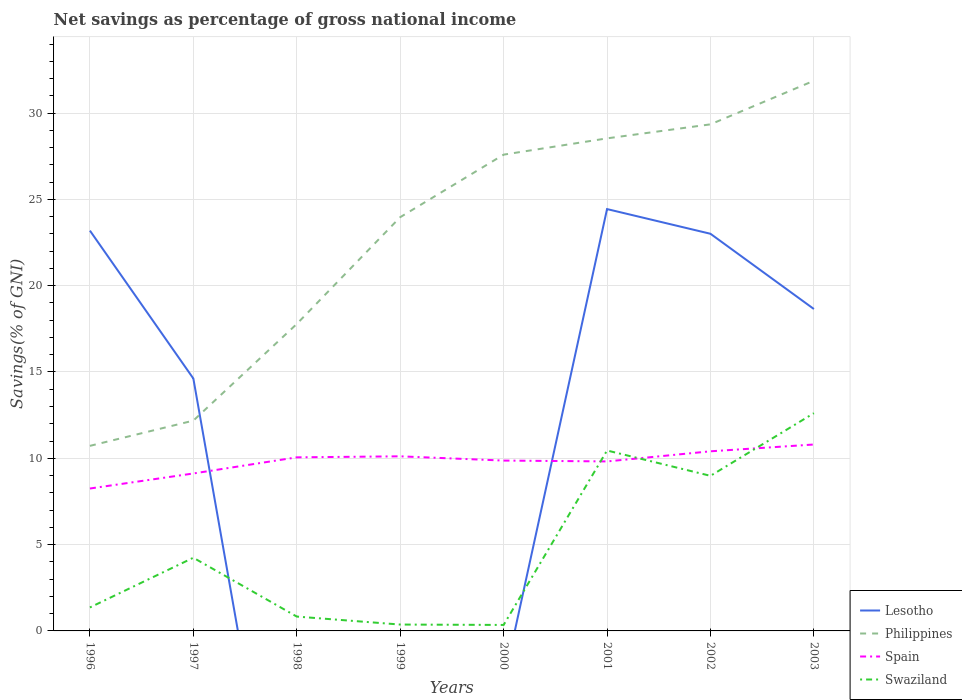Across all years, what is the maximum total savings in Lesotho?
Make the answer very short. 0. What is the total total savings in Swaziland in the graph?
Give a very brief answer. -8.62. What is the difference between the highest and the second highest total savings in Philippines?
Provide a succinct answer. 21.15. What is the difference between the highest and the lowest total savings in Spain?
Your answer should be very brief. 6. Is the total savings in Lesotho strictly greater than the total savings in Philippines over the years?
Keep it short and to the point. No. How many lines are there?
Your answer should be compact. 4. How many years are there in the graph?
Give a very brief answer. 8. What is the difference between two consecutive major ticks on the Y-axis?
Your answer should be very brief. 5. Are the values on the major ticks of Y-axis written in scientific E-notation?
Your answer should be very brief. No. Does the graph contain grids?
Your response must be concise. Yes. What is the title of the graph?
Offer a terse response. Net savings as percentage of gross national income. Does "Ireland" appear as one of the legend labels in the graph?
Offer a very short reply. No. What is the label or title of the Y-axis?
Provide a short and direct response. Savings(% of GNI). What is the Savings(% of GNI) in Lesotho in 1996?
Your answer should be very brief. 23.19. What is the Savings(% of GNI) of Philippines in 1996?
Give a very brief answer. 10.72. What is the Savings(% of GNI) in Spain in 1996?
Provide a succinct answer. 8.25. What is the Savings(% of GNI) in Swaziland in 1996?
Make the answer very short. 1.36. What is the Savings(% of GNI) in Lesotho in 1997?
Your response must be concise. 14.62. What is the Savings(% of GNI) of Philippines in 1997?
Provide a succinct answer. 12.18. What is the Savings(% of GNI) of Spain in 1997?
Keep it short and to the point. 9.12. What is the Savings(% of GNI) in Swaziland in 1997?
Your response must be concise. 4.24. What is the Savings(% of GNI) in Lesotho in 1998?
Offer a very short reply. 0. What is the Savings(% of GNI) in Philippines in 1998?
Ensure brevity in your answer.  17.78. What is the Savings(% of GNI) of Spain in 1998?
Ensure brevity in your answer.  10.06. What is the Savings(% of GNI) of Swaziland in 1998?
Provide a succinct answer. 0.83. What is the Savings(% of GNI) of Lesotho in 1999?
Keep it short and to the point. 0. What is the Savings(% of GNI) of Philippines in 1999?
Your answer should be very brief. 23.97. What is the Savings(% of GNI) in Spain in 1999?
Offer a terse response. 10.12. What is the Savings(% of GNI) of Swaziland in 1999?
Keep it short and to the point. 0.37. What is the Savings(% of GNI) in Lesotho in 2000?
Provide a succinct answer. 0. What is the Savings(% of GNI) in Philippines in 2000?
Your answer should be compact. 27.59. What is the Savings(% of GNI) in Spain in 2000?
Provide a short and direct response. 9.87. What is the Savings(% of GNI) in Swaziland in 2000?
Make the answer very short. 0.35. What is the Savings(% of GNI) of Lesotho in 2001?
Offer a very short reply. 24.44. What is the Savings(% of GNI) in Philippines in 2001?
Your response must be concise. 28.54. What is the Savings(% of GNI) of Spain in 2001?
Keep it short and to the point. 9.82. What is the Savings(% of GNI) in Swaziland in 2001?
Your response must be concise. 10.45. What is the Savings(% of GNI) of Lesotho in 2002?
Give a very brief answer. 23.01. What is the Savings(% of GNI) of Philippines in 2002?
Provide a short and direct response. 29.35. What is the Savings(% of GNI) in Spain in 2002?
Your response must be concise. 10.41. What is the Savings(% of GNI) in Swaziland in 2002?
Ensure brevity in your answer.  8.98. What is the Savings(% of GNI) in Lesotho in 2003?
Provide a succinct answer. 18.65. What is the Savings(% of GNI) of Philippines in 2003?
Give a very brief answer. 31.87. What is the Savings(% of GNI) in Spain in 2003?
Make the answer very short. 10.8. What is the Savings(% of GNI) of Swaziland in 2003?
Provide a short and direct response. 12.61. Across all years, what is the maximum Savings(% of GNI) of Lesotho?
Ensure brevity in your answer.  24.44. Across all years, what is the maximum Savings(% of GNI) of Philippines?
Your answer should be very brief. 31.87. Across all years, what is the maximum Savings(% of GNI) in Spain?
Your answer should be very brief. 10.8. Across all years, what is the maximum Savings(% of GNI) of Swaziland?
Provide a short and direct response. 12.61. Across all years, what is the minimum Savings(% of GNI) of Lesotho?
Provide a succinct answer. 0. Across all years, what is the minimum Savings(% of GNI) in Philippines?
Your answer should be compact. 10.72. Across all years, what is the minimum Savings(% of GNI) of Spain?
Give a very brief answer. 8.25. Across all years, what is the minimum Savings(% of GNI) of Swaziland?
Offer a terse response. 0.35. What is the total Savings(% of GNI) in Lesotho in the graph?
Offer a terse response. 103.91. What is the total Savings(% of GNI) of Philippines in the graph?
Provide a succinct answer. 182. What is the total Savings(% of GNI) in Spain in the graph?
Offer a very short reply. 78.43. What is the total Savings(% of GNI) in Swaziland in the graph?
Your response must be concise. 39.2. What is the difference between the Savings(% of GNI) in Lesotho in 1996 and that in 1997?
Provide a short and direct response. 8.57. What is the difference between the Savings(% of GNI) in Philippines in 1996 and that in 1997?
Provide a short and direct response. -1.46. What is the difference between the Savings(% of GNI) of Spain in 1996 and that in 1997?
Your response must be concise. -0.87. What is the difference between the Savings(% of GNI) in Swaziland in 1996 and that in 1997?
Make the answer very short. -2.88. What is the difference between the Savings(% of GNI) of Philippines in 1996 and that in 1998?
Offer a very short reply. -7.06. What is the difference between the Savings(% of GNI) in Spain in 1996 and that in 1998?
Offer a terse response. -1.81. What is the difference between the Savings(% of GNI) in Swaziland in 1996 and that in 1998?
Your answer should be very brief. 0.53. What is the difference between the Savings(% of GNI) in Philippines in 1996 and that in 1999?
Keep it short and to the point. -13.25. What is the difference between the Savings(% of GNI) in Spain in 1996 and that in 1999?
Provide a succinct answer. -1.87. What is the difference between the Savings(% of GNI) of Swaziland in 1996 and that in 1999?
Provide a succinct answer. 0.99. What is the difference between the Savings(% of GNI) in Philippines in 1996 and that in 2000?
Give a very brief answer. -16.87. What is the difference between the Savings(% of GNI) in Spain in 1996 and that in 2000?
Your response must be concise. -1.62. What is the difference between the Savings(% of GNI) of Swaziland in 1996 and that in 2000?
Provide a short and direct response. 1.01. What is the difference between the Savings(% of GNI) of Lesotho in 1996 and that in 2001?
Keep it short and to the point. -1.25. What is the difference between the Savings(% of GNI) of Philippines in 1996 and that in 2001?
Ensure brevity in your answer.  -17.81. What is the difference between the Savings(% of GNI) in Spain in 1996 and that in 2001?
Provide a succinct answer. -1.57. What is the difference between the Savings(% of GNI) in Swaziland in 1996 and that in 2001?
Your answer should be very brief. -9.09. What is the difference between the Savings(% of GNI) of Lesotho in 1996 and that in 2002?
Offer a very short reply. 0.18. What is the difference between the Savings(% of GNI) of Philippines in 1996 and that in 2002?
Make the answer very short. -18.63. What is the difference between the Savings(% of GNI) in Spain in 1996 and that in 2002?
Make the answer very short. -2.16. What is the difference between the Savings(% of GNI) of Swaziland in 1996 and that in 2002?
Your response must be concise. -7.62. What is the difference between the Savings(% of GNI) of Lesotho in 1996 and that in 2003?
Provide a short and direct response. 4.54. What is the difference between the Savings(% of GNI) in Philippines in 1996 and that in 2003?
Provide a succinct answer. -21.15. What is the difference between the Savings(% of GNI) of Spain in 1996 and that in 2003?
Your answer should be compact. -2.55. What is the difference between the Savings(% of GNI) in Swaziland in 1996 and that in 2003?
Ensure brevity in your answer.  -11.25. What is the difference between the Savings(% of GNI) in Philippines in 1997 and that in 1998?
Offer a terse response. -5.6. What is the difference between the Savings(% of GNI) in Spain in 1997 and that in 1998?
Give a very brief answer. -0.93. What is the difference between the Savings(% of GNI) in Swaziland in 1997 and that in 1998?
Your answer should be compact. 3.41. What is the difference between the Savings(% of GNI) in Philippines in 1997 and that in 1999?
Provide a succinct answer. -11.79. What is the difference between the Savings(% of GNI) in Spain in 1997 and that in 1999?
Your answer should be very brief. -0.99. What is the difference between the Savings(% of GNI) of Swaziland in 1997 and that in 1999?
Your response must be concise. 3.87. What is the difference between the Savings(% of GNI) in Philippines in 1997 and that in 2000?
Offer a very short reply. -15.41. What is the difference between the Savings(% of GNI) of Spain in 1997 and that in 2000?
Keep it short and to the point. -0.75. What is the difference between the Savings(% of GNI) of Swaziland in 1997 and that in 2000?
Your response must be concise. 3.89. What is the difference between the Savings(% of GNI) in Lesotho in 1997 and that in 2001?
Your response must be concise. -9.81. What is the difference between the Savings(% of GNI) in Philippines in 1997 and that in 2001?
Offer a very short reply. -16.35. What is the difference between the Savings(% of GNI) of Spain in 1997 and that in 2001?
Ensure brevity in your answer.  -0.7. What is the difference between the Savings(% of GNI) of Swaziland in 1997 and that in 2001?
Offer a very short reply. -6.21. What is the difference between the Savings(% of GNI) of Lesotho in 1997 and that in 2002?
Provide a succinct answer. -8.38. What is the difference between the Savings(% of GNI) of Philippines in 1997 and that in 2002?
Give a very brief answer. -17.16. What is the difference between the Savings(% of GNI) in Spain in 1997 and that in 2002?
Provide a succinct answer. -1.28. What is the difference between the Savings(% of GNI) in Swaziland in 1997 and that in 2002?
Provide a succinct answer. -4.75. What is the difference between the Savings(% of GNI) in Lesotho in 1997 and that in 2003?
Keep it short and to the point. -4.03. What is the difference between the Savings(% of GNI) of Philippines in 1997 and that in 2003?
Give a very brief answer. -19.69. What is the difference between the Savings(% of GNI) in Spain in 1997 and that in 2003?
Keep it short and to the point. -1.68. What is the difference between the Savings(% of GNI) in Swaziland in 1997 and that in 2003?
Give a very brief answer. -8.37. What is the difference between the Savings(% of GNI) in Philippines in 1998 and that in 1999?
Your response must be concise. -6.19. What is the difference between the Savings(% of GNI) in Spain in 1998 and that in 1999?
Offer a terse response. -0.06. What is the difference between the Savings(% of GNI) in Swaziland in 1998 and that in 1999?
Ensure brevity in your answer.  0.46. What is the difference between the Savings(% of GNI) in Philippines in 1998 and that in 2000?
Provide a succinct answer. -9.81. What is the difference between the Savings(% of GNI) in Spain in 1998 and that in 2000?
Provide a short and direct response. 0.19. What is the difference between the Savings(% of GNI) in Swaziland in 1998 and that in 2000?
Ensure brevity in your answer.  0.48. What is the difference between the Savings(% of GNI) in Philippines in 1998 and that in 2001?
Give a very brief answer. -10.75. What is the difference between the Savings(% of GNI) in Spain in 1998 and that in 2001?
Make the answer very short. 0.24. What is the difference between the Savings(% of GNI) in Swaziland in 1998 and that in 2001?
Offer a terse response. -9.62. What is the difference between the Savings(% of GNI) in Philippines in 1998 and that in 2002?
Provide a short and direct response. -11.56. What is the difference between the Savings(% of GNI) in Spain in 1998 and that in 2002?
Give a very brief answer. -0.35. What is the difference between the Savings(% of GNI) in Swaziland in 1998 and that in 2002?
Your response must be concise. -8.15. What is the difference between the Savings(% of GNI) of Philippines in 1998 and that in 2003?
Keep it short and to the point. -14.09. What is the difference between the Savings(% of GNI) of Spain in 1998 and that in 2003?
Offer a terse response. -0.74. What is the difference between the Savings(% of GNI) of Swaziland in 1998 and that in 2003?
Ensure brevity in your answer.  -11.78. What is the difference between the Savings(% of GNI) in Philippines in 1999 and that in 2000?
Your answer should be compact. -3.62. What is the difference between the Savings(% of GNI) in Spain in 1999 and that in 2000?
Your answer should be compact. 0.25. What is the difference between the Savings(% of GNI) in Swaziland in 1999 and that in 2000?
Offer a terse response. 0.02. What is the difference between the Savings(% of GNI) of Philippines in 1999 and that in 2001?
Provide a short and direct response. -4.57. What is the difference between the Savings(% of GNI) of Spain in 1999 and that in 2001?
Provide a succinct answer. 0.3. What is the difference between the Savings(% of GNI) in Swaziland in 1999 and that in 2001?
Provide a succinct answer. -10.08. What is the difference between the Savings(% of GNI) in Philippines in 1999 and that in 2002?
Ensure brevity in your answer.  -5.38. What is the difference between the Savings(% of GNI) in Spain in 1999 and that in 2002?
Your answer should be compact. -0.29. What is the difference between the Savings(% of GNI) of Swaziland in 1999 and that in 2002?
Your response must be concise. -8.62. What is the difference between the Savings(% of GNI) of Philippines in 1999 and that in 2003?
Your response must be concise. -7.9. What is the difference between the Savings(% of GNI) of Spain in 1999 and that in 2003?
Provide a succinct answer. -0.68. What is the difference between the Savings(% of GNI) in Swaziland in 1999 and that in 2003?
Provide a succinct answer. -12.24. What is the difference between the Savings(% of GNI) of Philippines in 2000 and that in 2001?
Give a very brief answer. -0.94. What is the difference between the Savings(% of GNI) in Spain in 2000 and that in 2001?
Provide a short and direct response. 0.05. What is the difference between the Savings(% of GNI) in Swaziland in 2000 and that in 2001?
Your response must be concise. -10.11. What is the difference between the Savings(% of GNI) of Philippines in 2000 and that in 2002?
Offer a terse response. -1.76. What is the difference between the Savings(% of GNI) in Spain in 2000 and that in 2002?
Your answer should be compact. -0.54. What is the difference between the Savings(% of GNI) in Swaziland in 2000 and that in 2002?
Your answer should be very brief. -8.64. What is the difference between the Savings(% of GNI) in Philippines in 2000 and that in 2003?
Make the answer very short. -4.28. What is the difference between the Savings(% of GNI) in Spain in 2000 and that in 2003?
Give a very brief answer. -0.93. What is the difference between the Savings(% of GNI) in Swaziland in 2000 and that in 2003?
Provide a short and direct response. -12.27. What is the difference between the Savings(% of GNI) of Lesotho in 2001 and that in 2002?
Make the answer very short. 1.43. What is the difference between the Savings(% of GNI) in Philippines in 2001 and that in 2002?
Provide a succinct answer. -0.81. What is the difference between the Savings(% of GNI) of Spain in 2001 and that in 2002?
Make the answer very short. -0.59. What is the difference between the Savings(% of GNI) in Swaziland in 2001 and that in 2002?
Your answer should be very brief. 1.47. What is the difference between the Savings(% of GNI) in Lesotho in 2001 and that in 2003?
Keep it short and to the point. 5.79. What is the difference between the Savings(% of GNI) in Philippines in 2001 and that in 2003?
Provide a short and direct response. -3.34. What is the difference between the Savings(% of GNI) in Spain in 2001 and that in 2003?
Provide a short and direct response. -0.98. What is the difference between the Savings(% of GNI) of Swaziland in 2001 and that in 2003?
Offer a very short reply. -2.16. What is the difference between the Savings(% of GNI) in Lesotho in 2002 and that in 2003?
Provide a succinct answer. 4.36. What is the difference between the Savings(% of GNI) in Philippines in 2002 and that in 2003?
Your answer should be compact. -2.53. What is the difference between the Savings(% of GNI) in Spain in 2002 and that in 2003?
Your answer should be very brief. -0.39. What is the difference between the Savings(% of GNI) of Swaziland in 2002 and that in 2003?
Keep it short and to the point. -3.63. What is the difference between the Savings(% of GNI) of Lesotho in 1996 and the Savings(% of GNI) of Philippines in 1997?
Your answer should be compact. 11.01. What is the difference between the Savings(% of GNI) in Lesotho in 1996 and the Savings(% of GNI) in Spain in 1997?
Give a very brief answer. 14.07. What is the difference between the Savings(% of GNI) in Lesotho in 1996 and the Savings(% of GNI) in Swaziland in 1997?
Offer a very short reply. 18.95. What is the difference between the Savings(% of GNI) in Philippines in 1996 and the Savings(% of GNI) in Spain in 1997?
Offer a very short reply. 1.6. What is the difference between the Savings(% of GNI) of Philippines in 1996 and the Savings(% of GNI) of Swaziland in 1997?
Make the answer very short. 6.48. What is the difference between the Savings(% of GNI) in Spain in 1996 and the Savings(% of GNI) in Swaziland in 1997?
Provide a short and direct response. 4.01. What is the difference between the Savings(% of GNI) in Lesotho in 1996 and the Savings(% of GNI) in Philippines in 1998?
Your answer should be compact. 5.41. What is the difference between the Savings(% of GNI) in Lesotho in 1996 and the Savings(% of GNI) in Spain in 1998?
Your answer should be compact. 13.13. What is the difference between the Savings(% of GNI) of Lesotho in 1996 and the Savings(% of GNI) of Swaziland in 1998?
Give a very brief answer. 22.36. What is the difference between the Savings(% of GNI) in Philippines in 1996 and the Savings(% of GNI) in Spain in 1998?
Make the answer very short. 0.67. What is the difference between the Savings(% of GNI) of Philippines in 1996 and the Savings(% of GNI) of Swaziland in 1998?
Provide a short and direct response. 9.89. What is the difference between the Savings(% of GNI) in Spain in 1996 and the Savings(% of GNI) in Swaziland in 1998?
Offer a very short reply. 7.42. What is the difference between the Savings(% of GNI) of Lesotho in 1996 and the Savings(% of GNI) of Philippines in 1999?
Make the answer very short. -0.78. What is the difference between the Savings(% of GNI) in Lesotho in 1996 and the Savings(% of GNI) in Spain in 1999?
Offer a terse response. 13.08. What is the difference between the Savings(% of GNI) of Lesotho in 1996 and the Savings(% of GNI) of Swaziland in 1999?
Your answer should be very brief. 22.82. What is the difference between the Savings(% of GNI) in Philippines in 1996 and the Savings(% of GNI) in Spain in 1999?
Give a very brief answer. 0.61. What is the difference between the Savings(% of GNI) in Philippines in 1996 and the Savings(% of GNI) in Swaziland in 1999?
Make the answer very short. 10.35. What is the difference between the Savings(% of GNI) of Spain in 1996 and the Savings(% of GNI) of Swaziland in 1999?
Make the answer very short. 7.88. What is the difference between the Savings(% of GNI) of Lesotho in 1996 and the Savings(% of GNI) of Philippines in 2000?
Your response must be concise. -4.4. What is the difference between the Savings(% of GNI) of Lesotho in 1996 and the Savings(% of GNI) of Spain in 2000?
Make the answer very short. 13.32. What is the difference between the Savings(% of GNI) in Lesotho in 1996 and the Savings(% of GNI) in Swaziland in 2000?
Keep it short and to the point. 22.84. What is the difference between the Savings(% of GNI) of Philippines in 1996 and the Savings(% of GNI) of Spain in 2000?
Provide a succinct answer. 0.85. What is the difference between the Savings(% of GNI) of Philippines in 1996 and the Savings(% of GNI) of Swaziland in 2000?
Your answer should be compact. 10.37. What is the difference between the Savings(% of GNI) of Spain in 1996 and the Savings(% of GNI) of Swaziland in 2000?
Offer a terse response. 7.9. What is the difference between the Savings(% of GNI) of Lesotho in 1996 and the Savings(% of GNI) of Philippines in 2001?
Offer a very short reply. -5.34. What is the difference between the Savings(% of GNI) in Lesotho in 1996 and the Savings(% of GNI) in Spain in 2001?
Your answer should be compact. 13.37. What is the difference between the Savings(% of GNI) in Lesotho in 1996 and the Savings(% of GNI) in Swaziland in 2001?
Your answer should be compact. 12.74. What is the difference between the Savings(% of GNI) in Philippines in 1996 and the Savings(% of GNI) in Spain in 2001?
Your response must be concise. 0.9. What is the difference between the Savings(% of GNI) in Philippines in 1996 and the Savings(% of GNI) in Swaziland in 2001?
Your answer should be compact. 0.27. What is the difference between the Savings(% of GNI) in Spain in 1996 and the Savings(% of GNI) in Swaziland in 2001?
Your response must be concise. -2.2. What is the difference between the Savings(% of GNI) of Lesotho in 1996 and the Savings(% of GNI) of Philippines in 2002?
Your response must be concise. -6.16. What is the difference between the Savings(% of GNI) in Lesotho in 1996 and the Savings(% of GNI) in Spain in 2002?
Your answer should be very brief. 12.79. What is the difference between the Savings(% of GNI) of Lesotho in 1996 and the Savings(% of GNI) of Swaziland in 2002?
Your response must be concise. 14.21. What is the difference between the Savings(% of GNI) of Philippines in 1996 and the Savings(% of GNI) of Spain in 2002?
Your answer should be compact. 0.32. What is the difference between the Savings(% of GNI) of Philippines in 1996 and the Savings(% of GNI) of Swaziland in 2002?
Keep it short and to the point. 1.74. What is the difference between the Savings(% of GNI) in Spain in 1996 and the Savings(% of GNI) in Swaziland in 2002?
Make the answer very short. -0.73. What is the difference between the Savings(% of GNI) of Lesotho in 1996 and the Savings(% of GNI) of Philippines in 2003?
Make the answer very short. -8.68. What is the difference between the Savings(% of GNI) in Lesotho in 1996 and the Savings(% of GNI) in Spain in 2003?
Make the answer very short. 12.39. What is the difference between the Savings(% of GNI) in Lesotho in 1996 and the Savings(% of GNI) in Swaziland in 2003?
Make the answer very short. 10.58. What is the difference between the Savings(% of GNI) of Philippines in 1996 and the Savings(% of GNI) of Spain in 2003?
Ensure brevity in your answer.  -0.08. What is the difference between the Savings(% of GNI) in Philippines in 1996 and the Savings(% of GNI) in Swaziland in 2003?
Give a very brief answer. -1.89. What is the difference between the Savings(% of GNI) in Spain in 1996 and the Savings(% of GNI) in Swaziland in 2003?
Give a very brief answer. -4.36. What is the difference between the Savings(% of GNI) of Lesotho in 1997 and the Savings(% of GNI) of Philippines in 1998?
Provide a short and direct response. -3.16. What is the difference between the Savings(% of GNI) in Lesotho in 1997 and the Savings(% of GNI) in Spain in 1998?
Your response must be concise. 4.57. What is the difference between the Savings(% of GNI) in Lesotho in 1997 and the Savings(% of GNI) in Swaziland in 1998?
Make the answer very short. 13.79. What is the difference between the Savings(% of GNI) in Philippines in 1997 and the Savings(% of GNI) in Spain in 1998?
Give a very brief answer. 2.13. What is the difference between the Savings(% of GNI) in Philippines in 1997 and the Savings(% of GNI) in Swaziland in 1998?
Your response must be concise. 11.35. What is the difference between the Savings(% of GNI) of Spain in 1997 and the Savings(% of GNI) of Swaziland in 1998?
Provide a succinct answer. 8.29. What is the difference between the Savings(% of GNI) of Lesotho in 1997 and the Savings(% of GNI) of Philippines in 1999?
Your answer should be compact. -9.34. What is the difference between the Savings(% of GNI) of Lesotho in 1997 and the Savings(% of GNI) of Spain in 1999?
Your answer should be compact. 4.51. What is the difference between the Savings(% of GNI) in Lesotho in 1997 and the Savings(% of GNI) in Swaziland in 1999?
Make the answer very short. 14.25. What is the difference between the Savings(% of GNI) of Philippines in 1997 and the Savings(% of GNI) of Spain in 1999?
Your response must be concise. 2.07. What is the difference between the Savings(% of GNI) of Philippines in 1997 and the Savings(% of GNI) of Swaziland in 1999?
Provide a succinct answer. 11.81. What is the difference between the Savings(% of GNI) of Spain in 1997 and the Savings(% of GNI) of Swaziland in 1999?
Your answer should be very brief. 8.75. What is the difference between the Savings(% of GNI) of Lesotho in 1997 and the Savings(% of GNI) of Philippines in 2000?
Provide a short and direct response. -12.97. What is the difference between the Savings(% of GNI) of Lesotho in 1997 and the Savings(% of GNI) of Spain in 2000?
Make the answer very short. 4.75. What is the difference between the Savings(% of GNI) of Lesotho in 1997 and the Savings(% of GNI) of Swaziland in 2000?
Keep it short and to the point. 14.28. What is the difference between the Savings(% of GNI) of Philippines in 1997 and the Savings(% of GNI) of Spain in 2000?
Offer a terse response. 2.31. What is the difference between the Savings(% of GNI) in Philippines in 1997 and the Savings(% of GNI) in Swaziland in 2000?
Give a very brief answer. 11.84. What is the difference between the Savings(% of GNI) of Spain in 1997 and the Savings(% of GNI) of Swaziland in 2000?
Your answer should be compact. 8.77. What is the difference between the Savings(% of GNI) in Lesotho in 1997 and the Savings(% of GNI) in Philippines in 2001?
Keep it short and to the point. -13.91. What is the difference between the Savings(% of GNI) in Lesotho in 1997 and the Savings(% of GNI) in Spain in 2001?
Your answer should be very brief. 4.8. What is the difference between the Savings(% of GNI) of Lesotho in 1997 and the Savings(% of GNI) of Swaziland in 2001?
Offer a very short reply. 4.17. What is the difference between the Savings(% of GNI) in Philippines in 1997 and the Savings(% of GNI) in Spain in 2001?
Provide a succinct answer. 2.36. What is the difference between the Savings(% of GNI) in Philippines in 1997 and the Savings(% of GNI) in Swaziland in 2001?
Provide a succinct answer. 1.73. What is the difference between the Savings(% of GNI) of Spain in 1997 and the Savings(% of GNI) of Swaziland in 2001?
Offer a very short reply. -1.33. What is the difference between the Savings(% of GNI) in Lesotho in 1997 and the Savings(% of GNI) in Philippines in 2002?
Your answer should be very brief. -14.72. What is the difference between the Savings(% of GNI) of Lesotho in 1997 and the Savings(% of GNI) of Spain in 2002?
Offer a very short reply. 4.22. What is the difference between the Savings(% of GNI) of Lesotho in 1997 and the Savings(% of GNI) of Swaziland in 2002?
Make the answer very short. 5.64. What is the difference between the Savings(% of GNI) of Philippines in 1997 and the Savings(% of GNI) of Spain in 2002?
Provide a short and direct response. 1.78. What is the difference between the Savings(% of GNI) of Philippines in 1997 and the Savings(% of GNI) of Swaziland in 2002?
Your answer should be very brief. 3.2. What is the difference between the Savings(% of GNI) of Spain in 1997 and the Savings(% of GNI) of Swaziland in 2002?
Offer a terse response. 0.14. What is the difference between the Savings(% of GNI) of Lesotho in 1997 and the Savings(% of GNI) of Philippines in 2003?
Provide a short and direct response. -17.25. What is the difference between the Savings(% of GNI) in Lesotho in 1997 and the Savings(% of GNI) in Spain in 2003?
Keep it short and to the point. 3.82. What is the difference between the Savings(% of GNI) in Lesotho in 1997 and the Savings(% of GNI) in Swaziland in 2003?
Offer a terse response. 2.01. What is the difference between the Savings(% of GNI) in Philippines in 1997 and the Savings(% of GNI) in Spain in 2003?
Your response must be concise. 1.38. What is the difference between the Savings(% of GNI) in Philippines in 1997 and the Savings(% of GNI) in Swaziland in 2003?
Your response must be concise. -0.43. What is the difference between the Savings(% of GNI) of Spain in 1997 and the Savings(% of GNI) of Swaziland in 2003?
Your answer should be compact. -3.49. What is the difference between the Savings(% of GNI) in Philippines in 1998 and the Savings(% of GNI) in Spain in 1999?
Your response must be concise. 7.67. What is the difference between the Savings(% of GNI) of Philippines in 1998 and the Savings(% of GNI) of Swaziland in 1999?
Make the answer very short. 17.41. What is the difference between the Savings(% of GNI) in Spain in 1998 and the Savings(% of GNI) in Swaziland in 1999?
Your response must be concise. 9.69. What is the difference between the Savings(% of GNI) in Philippines in 1998 and the Savings(% of GNI) in Spain in 2000?
Your answer should be compact. 7.91. What is the difference between the Savings(% of GNI) of Philippines in 1998 and the Savings(% of GNI) of Swaziland in 2000?
Your answer should be very brief. 17.44. What is the difference between the Savings(% of GNI) in Spain in 1998 and the Savings(% of GNI) in Swaziland in 2000?
Keep it short and to the point. 9.71. What is the difference between the Savings(% of GNI) of Philippines in 1998 and the Savings(% of GNI) of Spain in 2001?
Your response must be concise. 7.96. What is the difference between the Savings(% of GNI) in Philippines in 1998 and the Savings(% of GNI) in Swaziland in 2001?
Your answer should be very brief. 7.33. What is the difference between the Savings(% of GNI) in Spain in 1998 and the Savings(% of GNI) in Swaziland in 2001?
Make the answer very short. -0.4. What is the difference between the Savings(% of GNI) in Philippines in 1998 and the Savings(% of GNI) in Spain in 2002?
Ensure brevity in your answer.  7.38. What is the difference between the Savings(% of GNI) in Philippines in 1998 and the Savings(% of GNI) in Swaziland in 2002?
Your answer should be very brief. 8.8. What is the difference between the Savings(% of GNI) in Spain in 1998 and the Savings(% of GNI) in Swaziland in 2002?
Ensure brevity in your answer.  1.07. What is the difference between the Savings(% of GNI) of Philippines in 1998 and the Savings(% of GNI) of Spain in 2003?
Ensure brevity in your answer.  6.98. What is the difference between the Savings(% of GNI) in Philippines in 1998 and the Savings(% of GNI) in Swaziland in 2003?
Your answer should be compact. 5.17. What is the difference between the Savings(% of GNI) in Spain in 1998 and the Savings(% of GNI) in Swaziland in 2003?
Your answer should be compact. -2.56. What is the difference between the Savings(% of GNI) of Philippines in 1999 and the Savings(% of GNI) of Spain in 2000?
Offer a very short reply. 14.1. What is the difference between the Savings(% of GNI) of Philippines in 1999 and the Savings(% of GNI) of Swaziland in 2000?
Provide a succinct answer. 23.62. What is the difference between the Savings(% of GNI) in Spain in 1999 and the Savings(% of GNI) in Swaziland in 2000?
Provide a succinct answer. 9.77. What is the difference between the Savings(% of GNI) in Philippines in 1999 and the Savings(% of GNI) in Spain in 2001?
Your response must be concise. 14.15. What is the difference between the Savings(% of GNI) of Philippines in 1999 and the Savings(% of GNI) of Swaziland in 2001?
Your answer should be compact. 13.52. What is the difference between the Savings(% of GNI) in Spain in 1999 and the Savings(% of GNI) in Swaziland in 2001?
Keep it short and to the point. -0.34. What is the difference between the Savings(% of GNI) in Philippines in 1999 and the Savings(% of GNI) in Spain in 2002?
Provide a succinct answer. 13.56. What is the difference between the Savings(% of GNI) in Philippines in 1999 and the Savings(% of GNI) in Swaziland in 2002?
Provide a succinct answer. 14.98. What is the difference between the Savings(% of GNI) of Spain in 1999 and the Savings(% of GNI) of Swaziland in 2002?
Provide a succinct answer. 1.13. What is the difference between the Savings(% of GNI) of Philippines in 1999 and the Savings(% of GNI) of Spain in 2003?
Make the answer very short. 13.17. What is the difference between the Savings(% of GNI) in Philippines in 1999 and the Savings(% of GNI) in Swaziland in 2003?
Your answer should be compact. 11.35. What is the difference between the Savings(% of GNI) of Spain in 1999 and the Savings(% of GNI) of Swaziland in 2003?
Provide a short and direct response. -2.5. What is the difference between the Savings(% of GNI) of Philippines in 2000 and the Savings(% of GNI) of Spain in 2001?
Your response must be concise. 17.77. What is the difference between the Savings(% of GNI) in Philippines in 2000 and the Savings(% of GNI) in Swaziland in 2001?
Your answer should be very brief. 17.14. What is the difference between the Savings(% of GNI) in Spain in 2000 and the Savings(% of GNI) in Swaziland in 2001?
Keep it short and to the point. -0.58. What is the difference between the Savings(% of GNI) of Philippines in 2000 and the Savings(% of GNI) of Spain in 2002?
Your response must be concise. 17.19. What is the difference between the Savings(% of GNI) in Philippines in 2000 and the Savings(% of GNI) in Swaziland in 2002?
Offer a terse response. 18.61. What is the difference between the Savings(% of GNI) of Spain in 2000 and the Savings(% of GNI) of Swaziland in 2002?
Your response must be concise. 0.88. What is the difference between the Savings(% of GNI) of Philippines in 2000 and the Savings(% of GNI) of Spain in 2003?
Provide a succinct answer. 16.79. What is the difference between the Savings(% of GNI) in Philippines in 2000 and the Savings(% of GNI) in Swaziland in 2003?
Offer a terse response. 14.98. What is the difference between the Savings(% of GNI) in Spain in 2000 and the Savings(% of GNI) in Swaziland in 2003?
Keep it short and to the point. -2.75. What is the difference between the Savings(% of GNI) of Lesotho in 2001 and the Savings(% of GNI) of Philippines in 2002?
Ensure brevity in your answer.  -4.91. What is the difference between the Savings(% of GNI) in Lesotho in 2001 and the Savings(% of GNI) in Spain in 2002?
Offer a terse response. 14.03. What is the difference between the Savings(% of GNI) of Lesotho in 2001 and the Savings(% of GNI) of Swaziland in 2002?
Ensure brevity in your answer.  15.45. What is the difference between the Savings(% of GNI) in Philippines in 2001 and the Savings(% of GNI) in Spain in 2002?
Keep it short and to the point. 18.13. What is the difference between the Savings(% of GNI) of Philippines in 2001 and the Savings(% of GNI) of Swaziland in 2002?
Your answer should be compact. 19.55. What is the difference between the Savings(% of GNI) in Spain in 2001 and the Savings(% of GNI) in Swaziland in 2002?
Offer a terse response. 0.83. What is the difference between the Savings(% of GNI) of Lesotho in 2001 and the Savings(% of GNI) of Philippines in 2003?
Offer a very short reply. -7.43. What is the difference between the Savings(% of GNI) in Lesotho in 2001 and the Savings(% of GNI) in Spain in 2003?
Ensure brevity in your answer.  13.64. What is the difference between the Savings(% of GNI) of Lesotho in 2001 and the Savings(% of GNI) of Swaziland in 2003?
Make the answer very short. 11.82. What is the difference between the Savings(% of GNI) of Philippines in 2001 and the Savings(% of GNI) of Spain in 2003?
Give a very brief answer. 17.74. What is the difference between the Savings(% of GNI) of Philippines in 2001 and the Savings(% of GNI) of Swaziland in 2003?
Offer a terse response. 15.92. What is the difference between the Savings(% of GNI) in Spain in 2001 and the Savings(% of GNI) in Swaziland in 2003?
Provide a short and direct response. -2.79. What is the difference between the Savings(% of GNI) in Lesotho in 2002 and the Savings(% of GNI) in Philippines in 2003?
Make the answer very short. -8.86. What is the difference between the Savings(% of GNI) of Lesotho in 2002 and the Savings(% of GNI) of Spain in 2003?
Make the answer very short. 12.21. What is the difference between the Savings(% of GNI) in Lesotho in 2002 and the Savings(% of GNI) in Swaziland in 2003?
Give a very brief answer. 10.39. What is the difference between the Savings(% of GNI) in Philippines in 2002 and the Savings(% of GNI) in Spain in 2003?
Offer a terse response. 18.55. What is the difference between the Savings(% of GNI) of Philippines in 2002 and the Savings(% of GNI) of Swaziland in 2003?
Keep it short and to the point. 16.73. What is the difference between the Savings(% of GNI) in Spain in 2002 and the Savings(% of GNI) in Swaziland in 2003?
Offer a terse response. -2.21. What is the average Savings(% of GNI) of Lesotho per year?
Ensure brevity in your answer.  12.99. What is the average Savings(% of GNI) of Philippines per year?
Your answer should be very brief. 22.75. What is the average Savings(% of GNI) in Spain per year?
Ensure brevity in your answer.  9.8. What is the average Savings(% of GNI) of Swaziland per year?
Offer a very short reply. 4.9. In the year 1996, what is the difference between the Savings(% of GNI) in Lesotho and Savings(% of GNI) in Philippines?
Offer a terse response. 12.47. In the year 1996, what is the difference between the Savings(% of GNI) of Lesotho and Savings(% of GNI) of Spain?
Make the answer very short. 14.94. In the year 1996, what is the difference between the Savings(% of GNI) in Lesotho and Savings(% of GNI) in Swaziland?
Provide a succinct answer. 21.83. In the year 1996, what is the difference between the Savings(% of GNI) of Philippines and Savings(% of GNI) of Spain?
Offer a terse response. 2.47. In the year 1996, what is the difference between the Savings(% of GNI) of Philippines and Savings(% of GNI) of Swaziland?
Your answer should be very brief. 9.36. In the year 1996, what is the difference between the Savings(% of GNI) of Spain and Savings(% of GNI) of Swaziland?
Provide a short and direct response. 6.89. In the year 1997, what is the difference between the Savings(% of GNI) of Lesotho and Savings(% of GNI) of Philippines?
Ensure brevity in your answer.  2.44. In the year 1997, what is the difference between the Savings(% of GNI) in Lesotho and Savings(% of GNI) in Spain?
Offer a terse response. 5.5. In the year 1997, what is the difference between the Savings(% of GNI) of Lesotho and Savings(% of GNI) of Swaziland?
Your response must be concise. 10.38. In the year 1997, what is the difference between the Savings(% of GNI) of Philippines and Savings(% of GNI) of Spain?
Your response must be concise. 3.06. In the year 1997, what is the difference between the Savings(% of GNI) of Philippines and Savings(% of GNI) of Swaziland?
Offer a very short reply. 7.94. In the year 1997, what is the difference between the Savings(% of GNI) in Spain and Savings(% of GNI) in Swaziland?
Your response must be concise. 4.88. In the year 1998, what is the difference between the Savings(% of GNI) in Philippines and Savings(% of GNI) in Spain?
Make the answer very short. 7.73. In the year 1998, what is the difference between the Savings(% of GNI) of Philippines and Savings(% of GNI) of Swaziland?
Your answer should be compact. 16.95. In the year 1998, what is the difference between the Savings(% of GNI) of Spain and Savings(% of GNI) of Swaziland?
Your answer should be compact. 9.22. In the year 1999, what is the difference between the Savings(% of GNI) of Philippines and Savings(% of GNI) of Spain?
Make the answer very short. 13.85. In the year 1999, what is the difference between the Savings(% of GNI) of Philippines and Savings(% of GNI) of Swaziland?
Ensure brevity in your answer.  23.6. In the year 1999, what is the difference between the Savings(% of GNI) in Spain and Savings(% of GNI) in Swaziland?
Offer a very short reply. 9.75. In the year 2000, what is the difference between the Savings(% of GNI) in Philippines and Savings(% of GNI) in Spain?
Keep it short and to the point. 17.72. In the year 2000, what is the difference between the Savings(% of GNI) in Philippines and Savings(% of GNI) in Swaziland?
Ensure brevity in your answer.  27.25. In the year 2000, what is the difference between the Savings(% of GNI) of Spain and Savings(% of GNI) of Swaziland?
Make the answer very short. 9.52. In the year 2001, what is the difference between the Savings(% of GNI) in Lesotho and Savings(% of GNI) in Philippines?
Give a very brief answer. -4.1. In the year 2001, what is the difference between the Savings(% of GNI) in Lesotho and Savings(% of GNI) in Spain?
Your response must be concise. 14.62. In the year 2001, what is the difference between the Savings(% of GNI) in Lesotho and Savings(% of GNI) in Swaziland?
Offer a terse response. 13.99. In the year 2001, what is the difference between the Savings(% of GNI) in Philippines and Savings(% of GNI) in Spain?
Your response must be concise. 18.72. In the year 2001, what is the difference between the Savings(% of GNI) of Philippines and Savings(% of GNI) of Swaziland?
Your answer should be very brief. 18.08. In the year 2001, what is the difference between the Savings(% of GNI) of Spain and Savings(% of GNI) of Swaziland?
Your response must be concise. -0.63. In the year 2002, what is the difference between the Savings(% of GNI) of Lesotho and Savings(% of GNI) of Philippines?
Keep it short and to the point. -6.34. In the year 2002, what is the difference between the Savings(% of GNI) of Lesotho and Savings(% of GNI) of Spain?
Offer a terse response. 12.6. In the year 2002, what is the difference between the Savings(% of GNI) in Lesotho and Savings(% of GNI) in Swaziland?
Offer a very short reply. 14.02. In the year 2002, what is the difference between the Savings(% of GNI) of Philippines and Savings(% of GNI) of Spain?
Your answer should be compact. 18.94. In the year 2002, what is the difference between the Savings(% of GNI) in Philippines and Savings(% of GNI) in Swaziland?
Provide a succinct answer. 20.36. In the year 2002, what is the difference between the Savings(% of GNI) of Spain and Savings(% of GNI) of Swaziland?
Give a very brief answer. 1.42. In the year 2003, what is the difference between the Savings(% of GNI) in Lesotho and Savings(% of GNI) in Philippines?
Your answer should be compact. -13.22. In the year 2003, what is the difference between the Savings(% of GNI) in Lesotho and Savings(% of GNI) in Spain?
Your response must be concise. 7.85. In the year 2003, what is the difference between the Savings(% of GNI) of Lesotho and Savings(% of GNI) of Swaziland?
Your response must be concise. 6.03. In the year 2003, what is the difference between the Savings(% of GNI) of Philippines and Savings(% of GNI) of Spain?
Provide a succinct answer. 21.07. In the year 2003, what is the difference between the Savings(% of GNI) of Philippines and Savings(% of GNI) of Swaziland?
Keep it short and to the point. 19.26. In the year 2003, what is the difference between the Savings(% of GNI) in Spain and Savings(% of GNI) in Swaziland?
Offer a very short reply. -1.81. What is the ratio of the Savings(% of GNI) of Lesotho in 1996 to that in 1997?
Give a very brief answer. 1.59. What is the ratio of the Savings(% of GNI) of Spain in 1996 to that in 1997?
Keep it short and to the point. 0.9. What is the ratio of the Savings(% of GNI) in Swaziland in 1996 to that in 1997?
Make the answer very short. 0.32. What is the ratio of the Savings(% of GNI) of Philippines in 1996 to that in 1998?
Provide a short and direct response. 0.6. What is the ratio of the Savings(% of GNI) in Spain in 1996 to that in 1998?
Your response must be concise. 0.82. What is the ratio of the Savings(% of GNI) in Swaziland in 1996 to that in 1998?
Your answer should be compact. 1.64. What is the ratio of the Savings(% of GNI) in Philippines in 1996 to that in 1999?
Keep it short and to the point. 0.45. What is the ratio of the Savings(% of GNI) of Spain in 1996 to that in 1999?
Provide a short and direct response. 0.82. What is the ratio of the Savings(% of GNI) of Swaziland in 1996 to that in 1999?
Provide a succinct answer. 3.68. What is the ratio of the Savings(% of GNI) in Philippines in 1996 to that in 2000?
Provide a succinct answer. 0.39. What is the ratio of the Savings(% of GNI) of Spain in 1996 to that in 2000?
Provide a succinct answer. 0.84. What is the ratio of the Savings(% of GNI) of Swaziland in 1996 to that in 2000?
Ensure brevity in your answer.  3.93. What is the ratio of the Savings(% of GNI) of Lesotho in 1996 to that in 2001?
Offer a very short reply. 0.95. What is the ratio of the Savings(% of GNI) in Philippines in 1996 to that in 2001?
Provide a short and direct response. 0.38. What is the ratio of the Savings(% of GNI) in Spain in 1996 to that in 2001?
Your answer should be very brief. 0.84. What is the ratio of the Savings(% of GNI) of Swaziland in 1996 to that in 2001?
Offer a terse response. 0.13. What is the ratio of the Savings(% of GNI) of Lesotho in 1996 to that in 2002?
Offer a terse response. 1.01. What is the ratio of the Savings(% of GNI) in Philippines in 1996 to that in 2002?
Keep it short and to the point. 0.37. What is the ratio of the Savings(% of GNI) in Spain in 1996 to that in 2002?
Keep it short and to the point. 0.79. What is the ratio of the Savings(% of GNI) in Swaziland in 1996 to that in 2002?
Keep it short and to the point. 0.15. What is the ratio of the Savings(% of GNI) of Lesotho in 1996 to that in 2003?
Offer a terse response. 1.24. What is the ratio of the Savings(% of GNI) of Philippines in 1996 to that in 2003?
Your answer should be compact. 0.34. What is the ratio of the Savings(% of GNI) of Spain in 1996 to that in 2003?
Keep it short and to the point. 0.76. What is the ratio of the Savings(% of GNI) in Swaziland in 1996 to that in 2003?
Keep it short and to the point. 0.11. What is the ratio of the Savings(% of GNI) of Philippines in 1997 to that in 1998?
Provide a succinct answer. 0.69. What is the ratio of the Savings(% of GNI) in Spain in 1997 to that in 1998?
Ensure brevity in your answer.  0.91. What is the ratio of the Savings(% of GNI) in Swaziland in 1997 to that in 1998?
Offer a terse response. 5.1. What is the ratio of the Savings(% of GNI) in Philippines in 1997 to that in 1999?
Your answer should be very brief. 0.51. What is the ratio of the Savings(% of GNI) in Spain in 1997 to that in 1999?
Provide a succinct answer. 0.9. What is the ratio of the Savings(% of GNI) in Swaziland in 1997 to that in 1999?
Provide a short and direct response. 11.49. What is the ratio of the Savings(% of GNI) in Philippines in 1997 to that in 2000?
Offer a terse response. 0.44. What is the ratio of the Savings(% of GNI) of Spain in 1997 to that in 2000?
Provide a succinct answer. 0.92. What is the ratio of the Savings(% of GNI) in Swaziland in 1997 to that in 2000?
Make the answer very short. 12.24. What is the ratio of the Savings(% of GNI) of Lesotho in 1997 to that in 2001?
Ensure brevity in your answer.  0.6. What is the ratio of the Savings(% of GNI) in Philippines in 1997 to that in 2001?
Provide a succinct answer. 0.43. What is the ratio of the Savings(% of GNI) of Spain in 1997 to that in 2001?
Offer a terse response. 0.93. What is the ratio of the Savings(% of GNI) in Swaziland in 1997 to that in 2001?
Provide a short and direct response. 0.41. What is the ratio of the Savings(% of GNI) in Lesotho in 1997 to that in 2002?
Offer a terse response. 0.64. What is the ratio of the Savings(% of GNI) of Philippines in 1997 to that in 2002?
Your response must be concise. 0.42. What is the ratio of the Savings(% of GNI) of Spain in 1997 to that in 2002?
Your response must be concise. 0.88. What is the ratio of the Savings(% of GNI) of Swaziland in 1997 to that in 2002?
Your answer should be compact. 0.47. What is the ratio of the Savings(% of GNI) in Lesotho in 1997 to that in 2003?
Give a very brief answer. 0.78. What is the ratio of the Savings(% of GNI) in Philippines in 1997 to that in 2003?
Your answer should be very brief. 0.38. What is the ratio of the Savings(% of GNI) of Spain in 1997 to that in 2003?
Your answer should be compact. 0.84. What is the ratio of the Savings(% of GNI) in Swaziland in 1997 to that in 2003?
Ensure brevity in your answer.  0.34. What is the ratio of the Savings(% of GNI) in Philippines in 1998 to that in 1999?
Keep it short and to the point. 0.74. What is the ratio of the Savings(% of GNI) in Swaziland in 1998 to that in 1999?
Offer a very short reply. 2.25. What is the ratio of the Savings(% of GNI) of Philippines in 1998 to that in 2000?
Provide a short and direct response. 0.64. What is the ratio of the Savings(% of GNI) of Swaziland in 1998 to that in 2000?
Make the answer very short. 2.4. What is the ratio of the Savings(% of GNI) in Philippines in 1998 to that in 2001?
Give a very brief answer. 0.62. What is the ratio of the Savings(% of GNI) of Spain in 1998 to that in 2001?
Your answer should be compact. 1.02. What is the ratio of the Savings(% of GNI) in Swaziland in 1998 to that in 2001?
Offer a very short reply. 0.08. What is the ratio of the Savings(% of GNI) in Philippines in 1998 to that in 2002?
Make the answer very short. 0.61. What is the ratio of the Savings(% of GNI) in Spain in 1998 to that in 2002?
Your response must be concise. 0.97. What is the ratio of the Savings(% of GNI) of Swaziland in 1998 to that in 2002?
Provide a succinct answer. 0.09. What is the ratio of the Savings(% of GNI) in Philippines in 1998 to that in 2003?
Your answer should be very brief. 0.56. What is the ratio of the Savings(% of GNI) of Spain in 1998 to that in 2003?
Make the answer very short. 0.93. What is the ratio of the Savings(% of GNI) of Swaziland in 1998 to that in 2003?
Your response must be concise. 0.07. What is the ratio of the Savings(% of GNI) in Philippines in 1999 to that in 2000?
Give a very brief answer. 0.87. What is the ratio of the Savings(% of GNI) of Swaziland in 1999 to that in 2000?
Keep it short and to the point. 1.07. What is the ratio of the Savings(% of GNI) in Philippines in 1999 to that in 2001?
Keep it short and to the point. 0.84. What is the ratio of the Savings(% of GNI) of Spain in 1999 to that in 2001?
Provide a succinct answer. 1.03. What is the ratio of the Savings(% of GNI) in Swaziland in 1999 to that in 2001?
Your answer should be very brief. 0.04. What is the ratio of the Savings(% of GNI) of Philippines in 1999 to that in 2002?
Give a very brief answer. 0.82. What is the ratio of the Savings(% of GNI) of Spain in 1999 to that in 2002?
Offer a terse response. 0.97. What is the ratio of the Savings(% of GNI) of Swaziland in 1999 to that in 2002?
Your response must be concise. 0.04. What is the ratio of the Savings(% of GNI) of Philippines in 1999 to that in 2003?
Offer a very short reply. 0.75. What is the ratio of the Savings(% of GNI) of Spain in 1999 to that in 2003?
Make the answer very short. 0.94. What is the ratio of the Savings(% of GNI) of Swaziland in 1999 to that in 2003?
Your response must be concise. 0.03. What is the ratio of the Savings(% of GNI) of Philippines in 2000 to that in 2001?
Keep it short and to the point. 0.97. What is the ratio of the Savings(% of GNI) of Spain in 2000 to that in 2001?
Offer a terse response. 1. What is the ratio of the Savings(% of GNI) of Swaziland in 2000 to that in 2001?
Provide a short and direct response. 0.03. What is the ratio of the Savings(% of GNI) of Philippines in 2000 to that in 2002?
Ensure brevity in your answer.  0.94. What is the ratio of the Savings(% of GNI) in Spain in 2000 to that in 2002?
Offer a very short reply. 0.95. What is the ratio of the Savings(% of GNI) of Swaziland in 2000 to that in 2002?
Keep it short and to the point. 0.04. What is the ratio of the Savings(% of GNI) in Philippines in 2000 to that in 2003?
Your answer should be compact. 0.87. What is the ratio of the Savings(% of GNI) in Spain in 2000 to that in 2003?
Your answer should be compact. 0.91. What is the ratio of the Savings(% of GNI) of Swaziland in 2000 to that in 2003?
Offer a terse response. 0.03. What is the ratio of the Savings(% of GNI) of Lesotho in 2001 to that in 2002?
Offer a very short reply. 1.06. What is the ratio of the Savings(% of GNI) of Philippines in 2001 to that in 2002?
Provide a short and direct response. 0.97. What is the ratio of the Savings(% of GNI) in Spain in 2001 to that in 2002?
Make the answer very short. 0.94. What is the ratio of the Savings(% of GNI) of Swaziland in 2001 to that in 2002?
Give a very brief answer. 1.16. What is the ratio of the Savings(% of GNI) of Lesotho in 2001 to that in 2003?
Offer a very short reply. 1.31. What is the ratio of the Savings(% of GNI) of Philippines in 2001 to that in 2003?
Your answer should be compact. 0.9. What is the ratio of the Savings(% of GNI) in Spain in 2001 to that in 2003?
Ensure brevity in your answer.  0.91. What is the ratio of the Savings(% of GNI) in Swaziland in 2001 to that in 2003?
Make the answer very short. 0.83. What is the ratio of the Savings(% of GNI) of Lesotho in 2002 to that in 2003?
Offer a terse response. 1.23. What is the ratio of the Savings(% of GNI) of Philippines in 2002 to that in 2003?
Your answer should be compact. 0.92. What is the ratio of the Savings(% of GNI) of Spain in 2002 to that in 2003?
Your answer should be very brief. 0.96. What is the ratio of the Savings(% of GNI) in Swaziland in 2002 to that in 2003?
Your response must be concise. 0.71. What is the difference between the highest and the second highest Savings(% of GNI) in Lesotho?
Give a very brief answer. 1.25. What is the difference between the highest and the second highest Savings(% of GNI) of Philippines?
Your response must be concise. 2.53. What is the difference between the highest and the second highest Savings(% of GNI) of Spain?
Your response must be concise. 0.39. What is the difference between the highest and the second highest Savings(% of GNI) of Swaziland?
Give a very brief answer. 2.16. What is the difference between the highest and the lowest Savings(% of GNI) in Lesotho?
Provide a succinct answer. 24.44. What is the difference between the highest and the lowest Savings(% of GNI) of Philippines?
Make the answer very short. 21.15. What is the difference between the highest and the lowest Savings(% of GNI) of Spain?
Your response must be concise. 2.55. What is the difference between the highest and the lowest Savings(% of GNI) in Swaziland?
Ensure brevity in your answer.  12.27. 